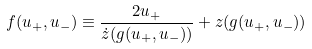<formula> <loc_0><loc_0><loc_500><loc_500>f ( u _ { + } , u _ { - } ) \equiv \frac { 2 u _ { + } } { \dot { z } ( g ( u _ { + } , u _ { - } ) ) } + z ( g ( u _ { + } , u _ { - } ) )</formula> 